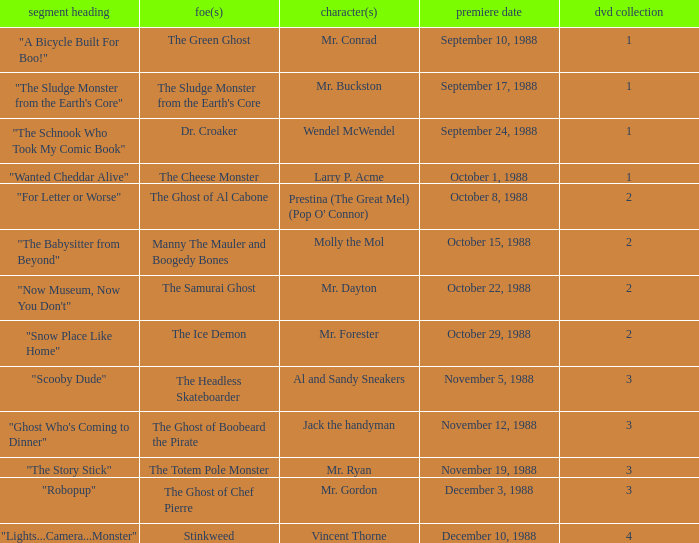Name the original airdate for mr. buckston September 17, 1988. 